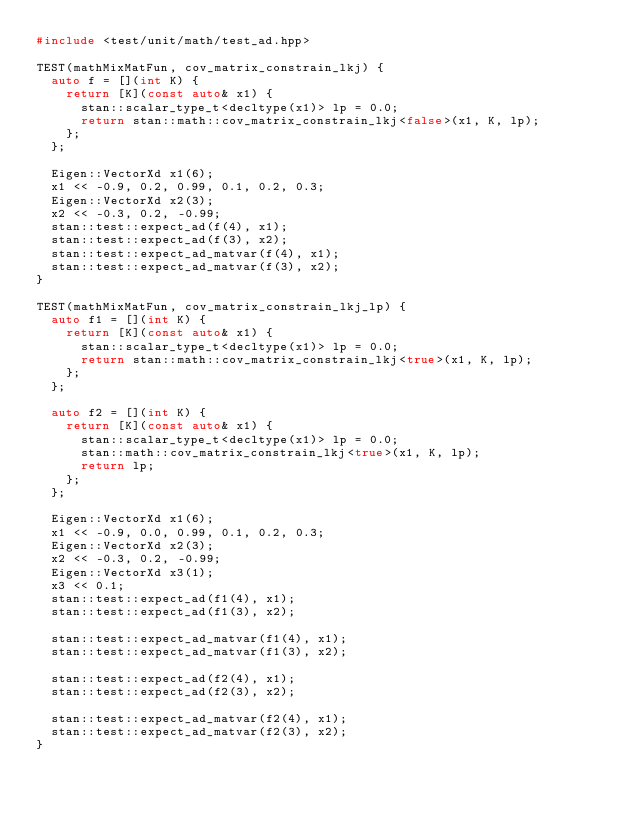<code> <loc_0><loc_0><loc_500><loc_500><_C++_>#include <test/unit/math/test_ad.hpp>

TEST(mathMixMatFun, cov_matrix_constrain_lkj) {
  auto f = [](int K) {
    return [K](const auto& x1) {
      stan::scalar_type_t<decltype(x1)> lp = 0.0;
      return stan::math::cov_matrix_constrain_lkj<false>(x1, K, lp);
    };
  };

  Eigen::VectorXd x1(6);
  x1 << -0.9, 0.2, 0.99, 0.1, 0.2, 0.3;
  Eigen::VectorXd x2(3);
  x2 << -0.3, 0.2, -0.99;
  stan::test::expect_ad(f(4), x1);
  stan::test::expect_ad(f(3), x2);
  stan::test::expect_ad_matvar(f(4), x1);
  stan::test::expect_ad_matvar(f(3), x2);
}

TEST(mathMixMatFun, cov_matrix_constrain_lkj_lp) {
  auto f1 = [](int K) {
    return [K](const auto& x1) {
      stan::scalar_type_t<decltype(x1)> lp = 0.0;
      return stan::math::cov_matrix_constrain_lkj<true>(x1, K, lp);
    };
  };

  auto f2 = [](int K) {
    return [K](const auto& x1) {
      stan::scalar_type_t<decltype(x1)> lp = 0.0;
      stan::math::cov_matrix_constrain_lkj<true>(x1, K, lp);
      return lp;
    };
  };

  Eigen::VectorXd x1(6);
  x1 << -0.9, 0.0, 0.99, 0.1, 0.2, 0.3;
  Eigen::VectorXd x2(3);
  x2 << -0.3, 0.2, -0.99;
  Eigen::VectorXd x3(1);
  x3 << 0.1;
  stan::test::expect_ad(f1(4), x1);
  stan::test::expect_ad(f1(3), x2);

  stan::test::expect_ad_matvar(f1(4), x1);
  stan::test::expect_ad_matvar(f1(3), x2);

  stan::test::expect_ad(f2(4), x1);
  stan::test::expect_ad(f2(3), x2);

  stan::test::expect_ad_matvar(f2(4), x1);
  stan::test::expect_ad_matvar(f2(3), x2);
}
</code> 